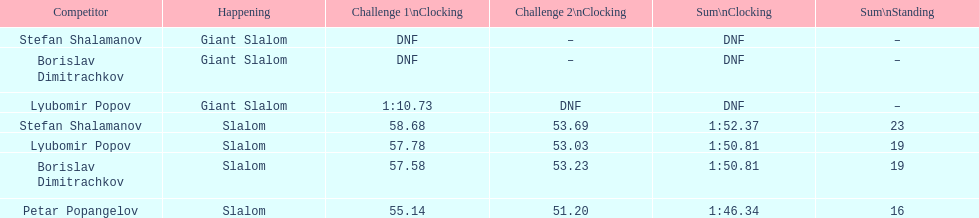Who possesses the greatest ranking? Petar Popangelov. 